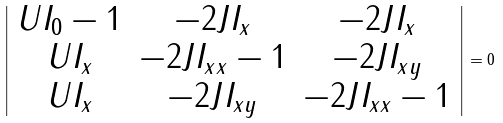<formula> <loc_0><loc_0><loc_500><loc_500>\left | \begin{array} { c c c } U I _ { 0 } - 1 & - 2 J I _ { x } & - 2 J I _ { x } \\ U I _ { x } & - 2 J I _ { x x } - 1 & - 2 J I _ { x y } \\ U I _ { x } & - 2 J I _ { x y } & - 2 J I _ { x x } - 1 \end{array} \right | = 0</formula> 